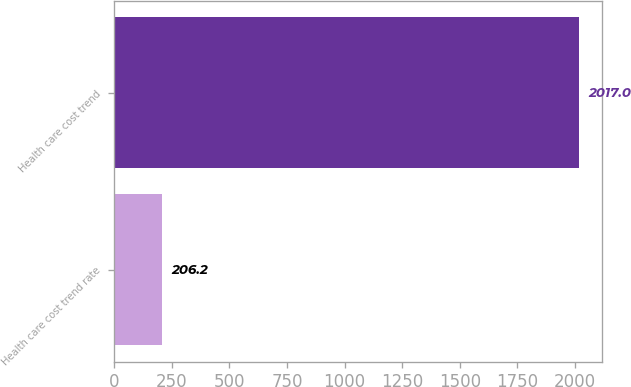Convert chart to OTSL. <chart><loc_0><loc_0><loc_500><loc_500><bar_chart><fcel>Health care cost trend rate<fcel>Health care cost trend<nl><fcel>206.2<fcel>2017<nl></chart> 